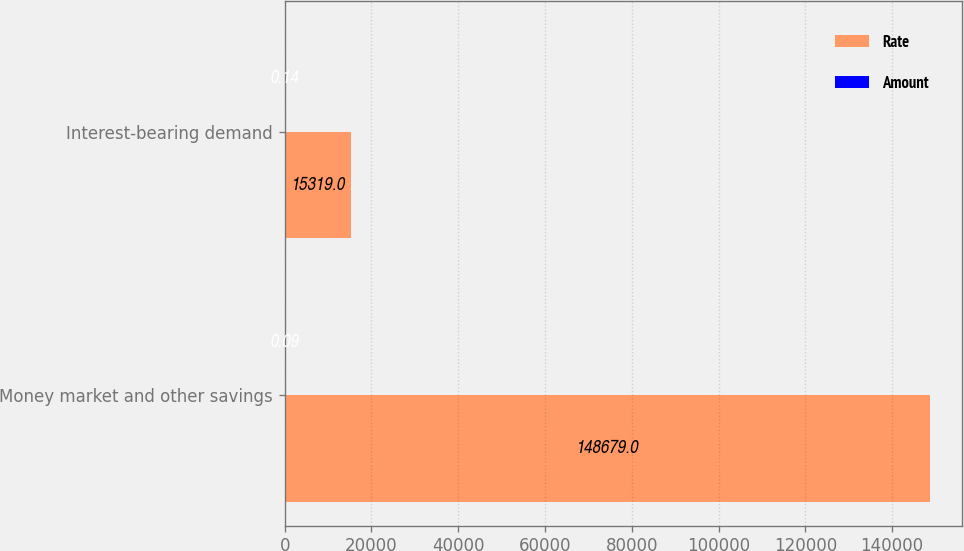<chart> <loc_0><loc_0><loc_500><loc_500><stacked_bar_chart><ecel><fcel>Money market and other savings<fcel>Interest-bearing demand<nl><fcel>Rate<fcel>148679<fcel>15319<nl><fcel>Amount<fcel>0.09<fcel>0.14<nl></chart> 